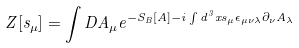Convert formula to latex. <formula><loc_0><loc_0><loc_500><loc_500>Z [ s _ { \mu } ] = \int D A _ { \mu } e ^ { - S _ { B } [ A ] - i \int d ^ { 3 } x s _ { \mu } \epsilon _ { \mu \nu \lambda } \partial _ { \nu } A _ { \lambda } }</formula> 